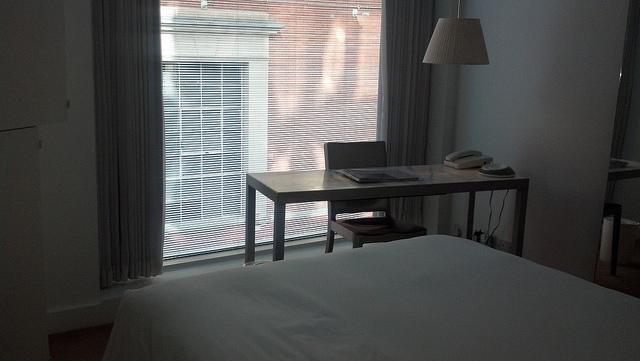Is there a light on?
Write a very short answer. No. Is the light on?
Short answer required. No. What is the function of this room?
Concise answer only. Bedroom. What piece  of furniture is next to the bed?
Write a very short answer. Desk. What three objects are on the nightstand?
Keep it brief. Phone, paper, clock. Is there only a bed in this room?
Short answer required. No. Is the light turned on or off?
Answer briefly. Off. Are the curtains opened or closed?
Short answer required. Open. What is outside the window?
Give a very brief answer. Building. Is there a key on the bed?
Be succinct. No. Does this room have any wall hangings?
Be succinct. No. Is the room clean?
Concise answer only. Yes. Is there a light turned on?
Give a very brief answer. No. What color is the lamp?
Answer briefly. White. Would people be able to see you pooping?
Short answer required. No. What's between the bed and the chair?
Answer briefly. Table. Is there a pillow on the bed?
Answer briefly. No. Are there any books on the table?
Short answer required. Yes. Is that a window or a light?
Answer briefly. Window. Is there a picture on the wall?
Keep it brief. No. Is the bed colorful?
Answer briefly. No. What room is this?
Answer briefly. Bedroom. Where is the lamp?
Write a very short answer. Table. Is this a hotel?
Give a very brief answer. Yes. Would it be possible to lay on either side of this mattress?
Answer briefly. Yes. Are the light sconces on or off?
Answer briefly. Off. Is the lamp on?
Keep it brief. No. Are there wooden shutters on the window?
Write a very short answer. No. Is there artwork on the wall?
Write a very short answer. No. 